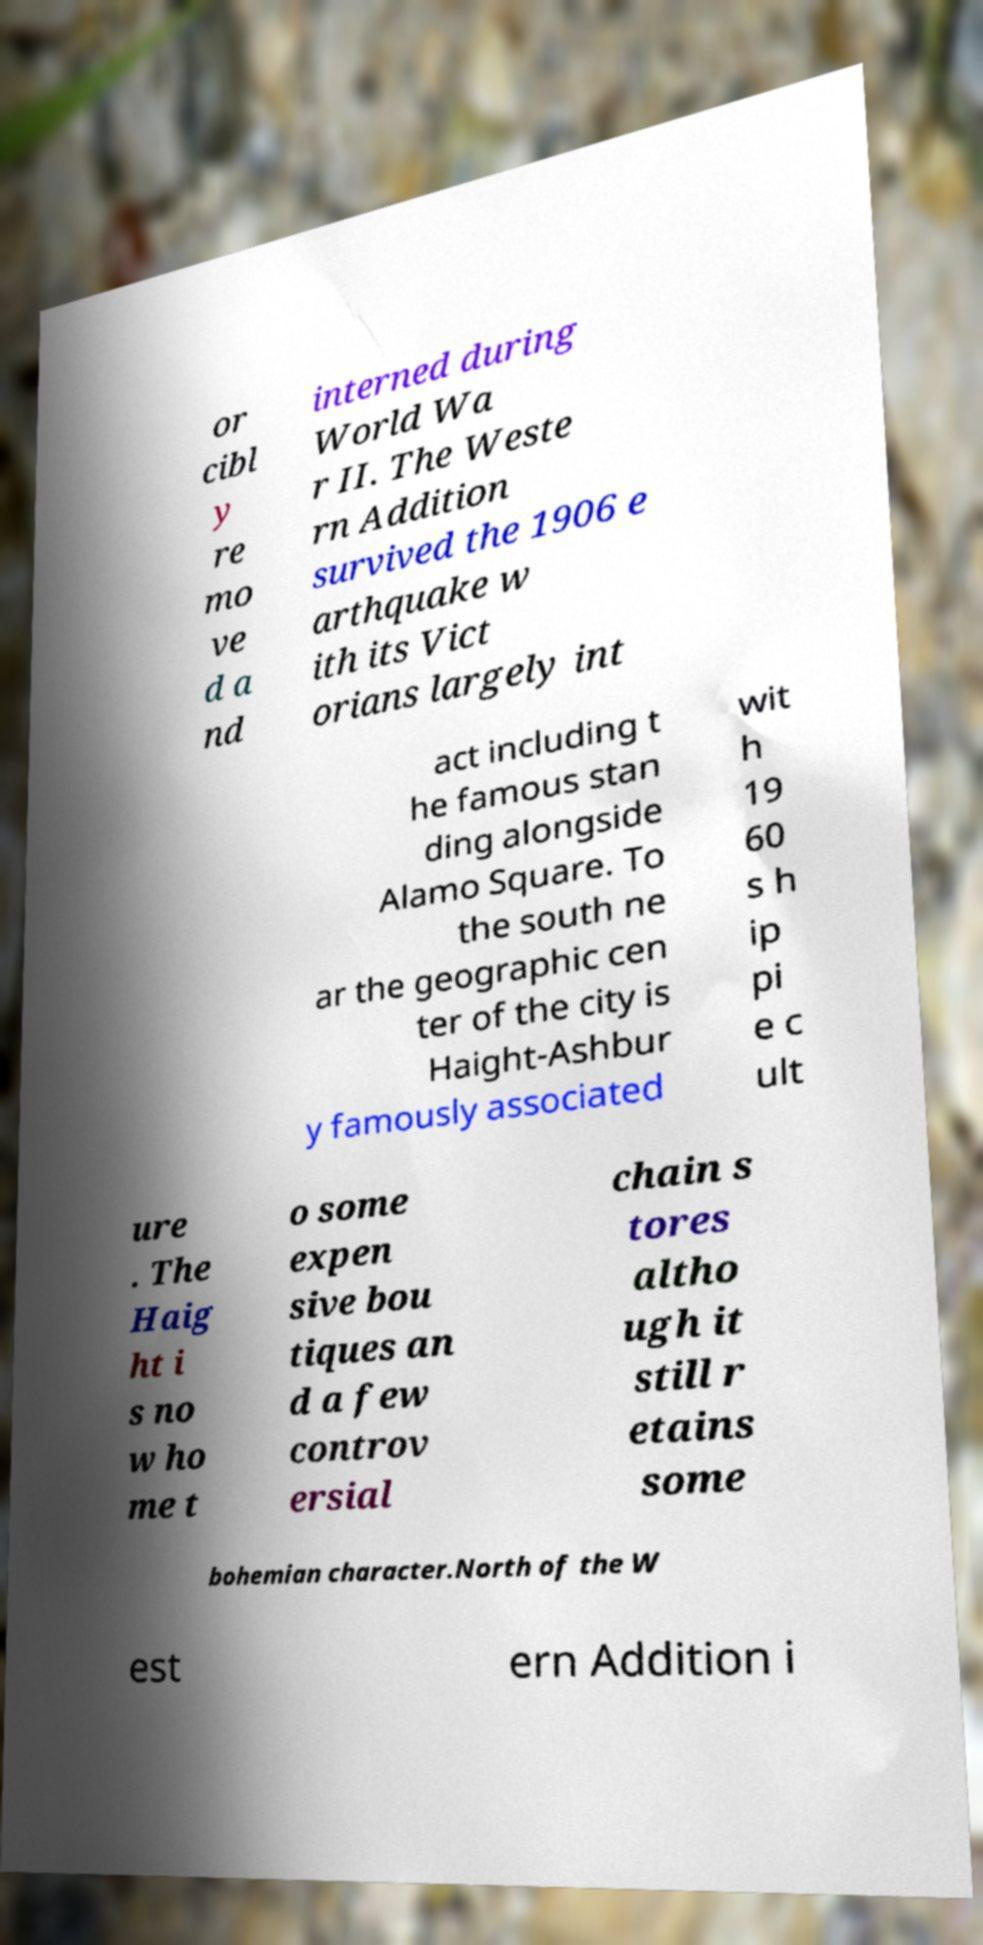I need the written content from this picture converted into text. Can you do that? or cibl y re mo ve d a nd interned during World Wa r II. The Weste rn Addition survived the 1906 e arthquake w ith its Vict orians largely int act including t he famous stan ding alongside Alamo Square. To the south ne ar the geographic cen ter of the city is Haight-Ashbur y famously associated wit h 19 60 s h ip pi e c ult ure . The Haig ht i s no w ho me t o some expen sive bou tiques an d a few controv ersial chain s tores altho ugh it still r etains some bohemian character.North of the W est ern Addition i 